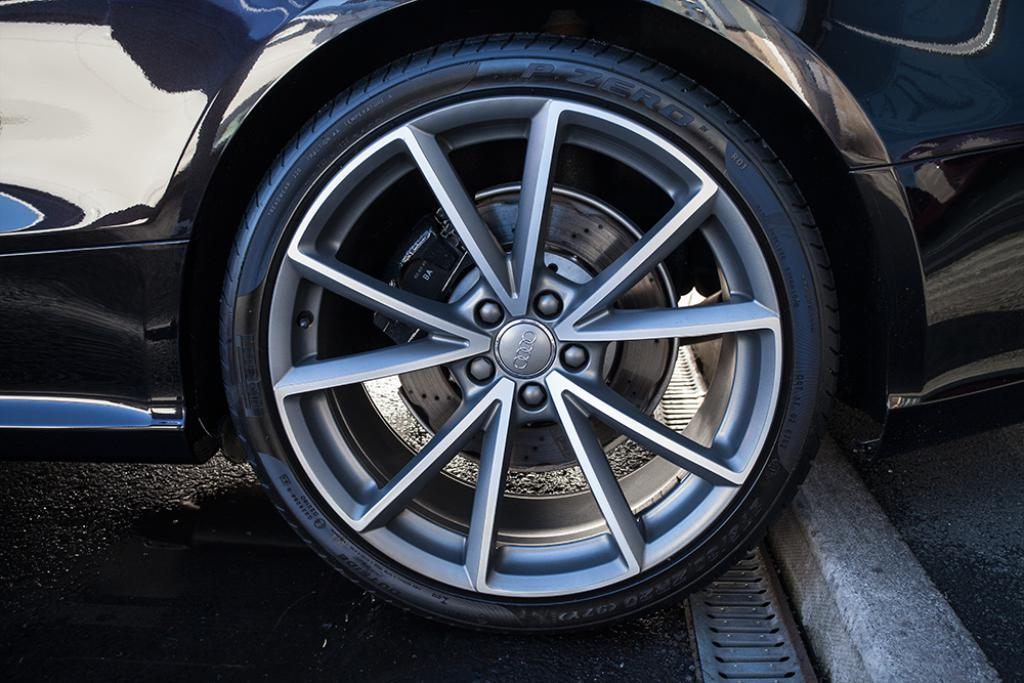What color is the car in the picture? The car in the picture is black. What part of the car is visible in the center of the image? The car's wheel is visible in the center of the image. What type of surface is visible at the bottom of the image? The road is visible at the bottom of the image. How far away is the business from the car in the image? There is no business visible in the image, so it is not possible to determine the distance between the car and a business. 